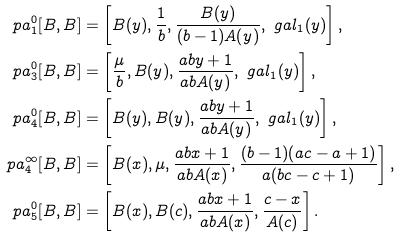<formula> <loc_0><loc_0><loc_500><loc_500>\ p a _ { 1 } ^ { 0 } [ B , B ] & = \left [ B ( y ) , \frac { 1 } { b } , \frac { B ( y ) } { ( b - 1 ) A ( y ) } , \ g a l _ { 1 } ( y ) \right ] , \\ \ p a _ { 3 } ^ { 0 } [ B , B ] & = \left [ \frac { \mu } { b } , B ( y ) , \frac { a b y + 1 } { a b A ( y ) } , \ g a l _ { 1 } ( y ) \right ] , \\ \ p a _ { 4 } ^ { 0 } [ B , B ] & = \left [ B ( y ) , B ( y ) , \frac { a b y + 1 } { a b A ( y ) } , \ g a l _ { 1 } ( y ) \right ] , \\ \ p a _ { 4 } ^ { \infty } [ B , B ] & = \left [ B ( x ) , \mu , \frac { a b x + 1 } { a b A ( x ) } , \frac { ( b - 1 ) ( a c - a + 1 ) } { a ( b c - c + 1 ) } \right ] , \\ \ p a _ { 5 } ^ { 0 } [ B , B ] & = \left [ B ( x ) , B ( c ) , \frac { a b x + 1 } { a b A ( x ) } , \frac { c - x } { A ( c ) } \right ] .</formula> 